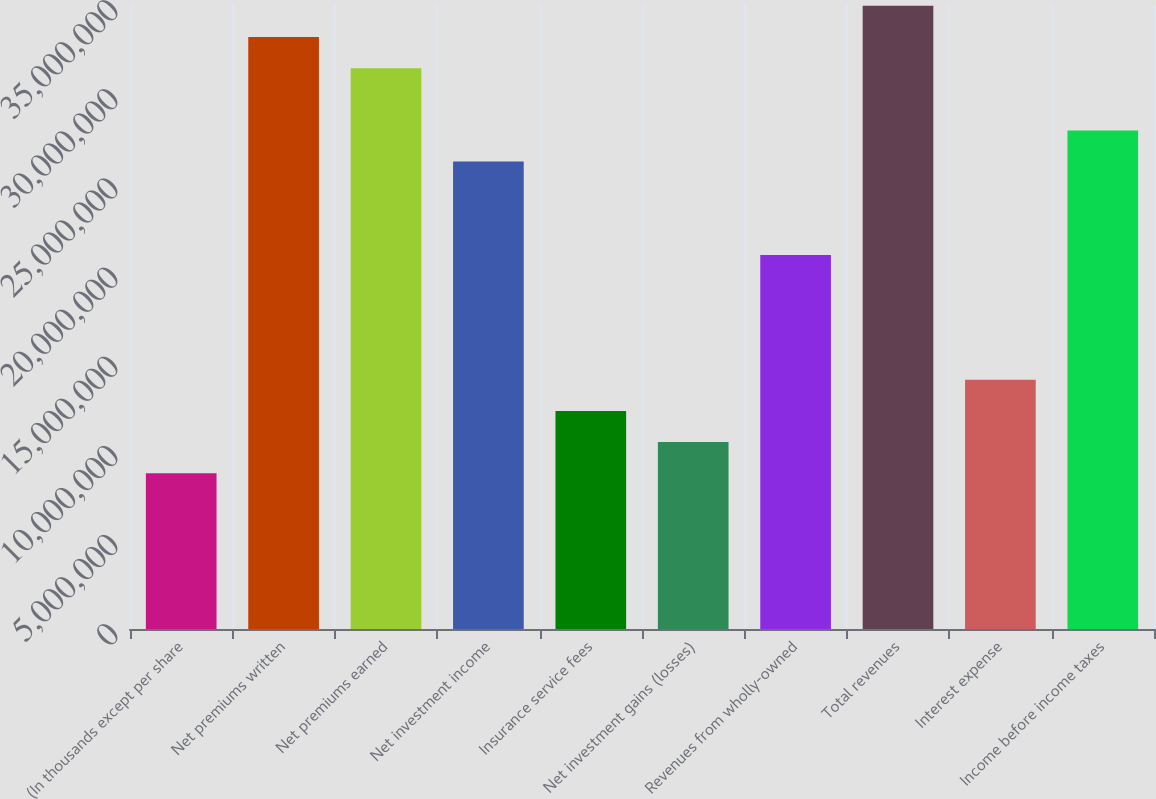<chart> <loc_0><loc_0><loc_500><loc_500><bar_chart><fcel>(In thousands except per share<fcel>Net premiums written<fcel>Net premiums earned<fcel>Net investment income<fcel>Insurance service fees<fcel>Net investment gains (losses)<fcel>Revenues from wholly-owned<fcel>Total revenues<fcel>Interest expense<fcel>Income before income taxes<nl><fcel>8.73854e+06<fcel>3.32064e+07<fcel>3.14587e+07<fcel>2.62156e+07<fcel>1.22339e+07<fcel>1.04862e+07<fcel>2.09725e+07<fcel>3.49541e+07<fcel>1.39817e+07<fcel>2.79633e+07<nl></chart> 